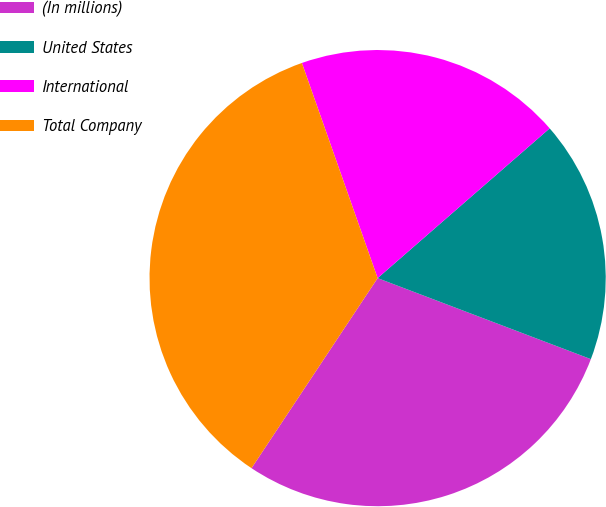Convert chart to OTSL. <chart><loc_0><loc_0><loc_500><loc_500><pie_chart><fcel>(In millions)<fcel>United States<fcel>International<fcel>Total Company<nl><fcel>28.55%<fcel>17.18%<fcel>18.99%<fcel>35.29%<nl></chart> 